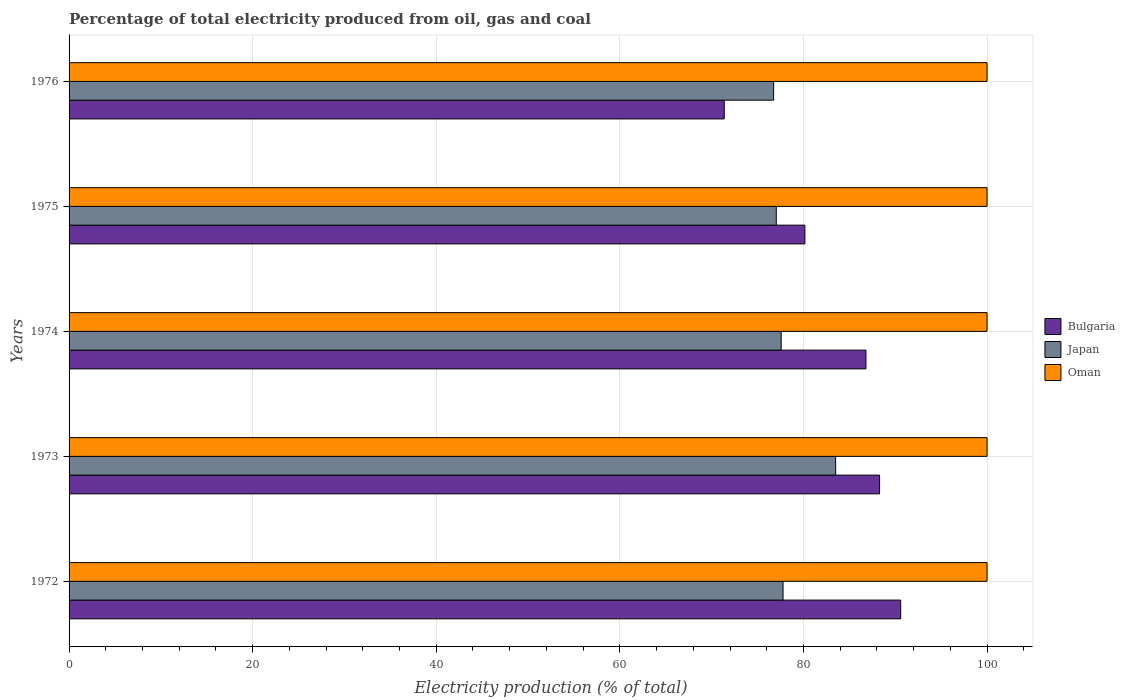How many groups of bars are there?
Provide a succinct answer. 5. Are the number of bars on each tick of the Y-axis equal?
Give a very brief answer. Yes. How many bars are there on the 2nd tick from the top?
Keep it short and to the point. 3. How many bars are there on the 3rd tick from the bottom?
Keep it short and to the point. 3. In how many cases, is the number of bars for a given year not equal to the number of legend labels?
Provide a short and direct response. 0. What is the electricity production in in Japan in 1975?
Ensure brevity in your answer.  77.04. Across all years, what is the maximum electricity production in in Bulgaria?
Make the answer very short. 90.59. Across all years, what is the minimum electricity production in in Bulgaria?
Your answer should be very brief. 71.37. In which year was the electricity production in in Japan minimum?
Give a very brief answer. 1976. What is the total electricity production in in Oman in the graph?
Your answer should be very brief. 500. What is the difference between the electricity production in in Japan in 1974 and that in 1975?
Make the answer very short. 0.53. What is the difference between the electricity production in in Japan in 1973 and the electricity production in in Oman in 1976?
Give a very brief answer. -16.49. What is the average electricity production in in Oman per year?
Your answer should be very brief. 100. In the year 1974, what is the difference between the electricity production in in Bulgaria and electricity production in in Oman?
Make the answer very short. -13.19. In how many years, is the electricity production in in Japan greater than 48 %?
Give a very brief answer. 5. Is the electricity production in in Oman in 1972 less than that in 1973?
Offer a very short reply. No. What is the difference between the highest and the second highest electricity production in in Japan?
Ensure brevity in your answer.  5.73. What does the 1st bar from the top in 1975 represents?
Provide a succinct answer. Oman. How many bars are there?
Make the answer very short. 15. Are all the bars in the graph horizontal?
Your response must be concise. Yes. What is the difference between two consecutive major ticks on the X-axis?
Give a very brief answer. 20. Does the graph contain any zero values?
Provide a succinct answer. No. Does the graph contain grids?
Your response must be concise. Yes. How many legend labels are there?
Your response must be concise. 3. How are the legend labels stacked?
Make the answer very short. Vertical. What is the title of the graph?
Offer a very short reply. Percentage of total electricity produced from oil, gas and coal. Does "Lebanon" appear as one of the legend labels in the graph?
Your answer should be compact. No. What is the label or title of the X-axis?
Ensure brevity in your answer.  Electricity production (% of total). What is the label or title of the Y-axis?
Offer a very short reply. Years. What is the Electricity production (% of total) in Bulgaria in 1972?
Your answer should be very brief. 90.59. What is the Electricity production (% of total) in Japan in 1972?
Provide a succinct answer. 77.78. What is the Electricity production (% of total) in Oman in 1972?
Keep it short and to the point. 100. What is the Electricity production (% of total) in Bulgaria in 1973?
Your answer should be very brief. 88.29. What is the Electricity production (% of total) of Japan in 1973?
Offer a very short reply. 83.51. What is the Electricity production (% of total) of Bulgaria in 1974?
Make the answer very short. 86.81. What is the Electricity production (% of total) in Japan in 1974?
Keep it short and to the point. 77.57. What is the Electricity production (% of total) in Oman in 1974?
Your answer should be compact. 100. What is the Electricity production (% of total) in Bulgaria in 1975?
Your answer should be compact. 80.16. What is the Electricity production (% of total) of Japan in 1975?
Your answer should be very brief. 77.04. What is the Electricity production (% of total) in Oman in 1975?
Offer a terse response. 100. What is the Electricity production (% of total) in Bulgaria in 1976?
Your answer should be compact. 71.37. What is the Electricity production (% of total) in Japan in 1976?
Keep it short and to the point. 76.75. Across all years, what is the maximum Electricity production (% of total) in Bulgaria?
Make the answer very short. 90.59. Across all years, what is the maximum Electricity production (% of total) in Japan?
Keep it short and to the point. 83.51. Across all years, what is the minimum Electricity production (% of total) of Bulgaria?
Your response must be concise. 71.37. Across all years, what is the minimum Electricity production (% of total) of Japan?
Make the answer very short. 76.75. Across all years, what is the minimum Electricity production (% of total) in Oman?
Your answer should be very brief. 100. What is the total Electricity production (% of total) of Bulgaria in the graph?
Offer a very short reply. 417.23. What is the total Electricity production (% of total) of Japan in the graph?
Keep it short and to the point. 392.65. What is the difference between the Electricity production (% of total) of Bulgaria in 1972 and that in 1973?
Offer a very short reply. 2.3. What is the difference between the Electricity production (% of total) in Japan in 1972 and that in 1973?
Keep it short and to the point. -5.73. What is the difference between the Electricity production (% of total) in Oman in 1972 and that in 1973?
Keep it short and to the point. 0. What is the difference between the Electricity production (% of total) in Bulgaria in 1972 and that in 1974?
Provide a succinct answer. 3.78. What is the difference between the Electricity production (% of total) of Japan in 1972 and that in 1974?
Ensure brevity in your answer.  0.2. What is the difference between the Electricity production (% of total) of Oman in 1972 and that in 1974?
Your answer should be very brief. 0. What is the difference between the Electricity production (% of total) of Bulgaria in 1972 and that in 1975?
Offer a very short reply. 10.43. What is the difference between the Electricity production (% of total) of Japan in 1972 and that in 1975?
Offer a terse response. 0.74. What is the difference between the Electricity production (% of total) of Oman in 1972 and that in 1975?
Ensure brevity in your answer.  0. What is the difference between the Electricity production (% of total) in Bulgaria in 1972 and that in 1976?
Provide a short and direct response. 19.22. What is the difference between the Electricity production (% of total) in Japan in 1972 and that in 1976?
Offer a very short reply. 1.03. What is the difference between the Electricity production (% of total) in Oman in 1972 and that in 1976?
Your answer should be very brief. 0. What is the difference between the Electricity production (% of total) in Bulgaria in 1973 and that in 1974?
Ensure brevity in your answer.  1.48. What is the difference between the Electricity production (% of total) of Japan in 1973 and that in 1974?
Keep it short and to the point. 5.93. What is the difference between the Electricity production (% of total) of Oman in 1973 and that in 1974?
Your answer should be compact. 0. What is the difference between the Electricity production (% of total) of Bulgaria in 1973 and that in 1975?
Offer a terse response. 8.13. What is the difference between the Electricity production (% of total) of Japan in 1973 and that in 1975?
Make the answer very short. 6.47. What is the difference between the Electricity production (% of total) of Bulgaria in 1973 and that in 1976?
Your answer should be compact. 16.92. What is the difference between the Electricity production (% of total) in Japan in 1973 and that in 1976?
Your answer should be compact. 6.76. What is the difference between the Electricity production (% of total) in Oman in 1973 and that in 1976?
Your response must be concise. 0. What is the difference between the Electricity production (% of total) in Bulgaria in 1974 and that in 1975?
Keep it short and to the point. 6.65. What is the difference between the Electricity production (% of total) in Japan in 1974 and that in 1975?
Offer a terse response. 0.53. What is the difference between the Electricity production (% of total) of Oman in 1974 and that in 1975?
Your response must be concise. 0. What is the difference between the Electricity production (% of total) of Bulgaria in 1974 and that in 1976?
Provide a succinct answer. 15.44. What is the difference between the Electricity production (% of total) in Japan in 1974 and that in 1976?
Provide a short and direct response. 0.82. What is the difference between the Electricity production (% of total) in Bulgaria in 1975 and that in 1976?
Make the answer very short. 8.79. What is the difference between the Electricity production (% of total) of Japan in 1975 and that in 1976?
Provide a succinct answer. 0.29. What is the difference between the Electricity production (% of total) in Oman in 1975 and that in 1976?
Provide a succinct answer. 0. What is the difference between the Electricity production (% of total) of Bulgaria in 1972 and the Electricity production (% of total) of Japan in 1973?
Your answer should be very brief. 7.09. What is the difference between the Electricity production (% of total) in Bulgaria in 1972 and the Electricity production (% of total) in Oman in 1973?
Your answer should be very brief. -9.41. What is the difference between the Electricity production (% of total) in Japan in 1972 and the Electricity production (% of total) in Oman in 1973?
Keep it short and to the point. -22.22. What is the difference between the Electricity production (% of total) of Bulgaria in 1972 and the Electricity production (% of total) of Japan in 1974?
Offer a terse response. 13.02. What is the difference between the Electricity production (% of total) of Bulgaria in 1972 and the Electricity production (% of total) of Oman in 1974?
Keep it short and to the point. -9.41. What is the difference between the Electricity production (% of total) of Japan in 1972 and the Electricity production (% of total) of Oman in 1974?
Your response must be concise. -22.22. What is the difference between the Electricity production (% of total) of Bulgaria in 1972 and the Electricity production (% of total) of Japan in 1975?
Ensure brevity in your answer.  13.55. What is the difference between the Electricity production (% of total) of Bulgaria in 1972 and the Electricity production (% of total) of Oman in 1975?
Make the answer very short. -9.41. What is the difference between the Electricity production (% of total) of Japan in 1972 and the Electricity production (% of total) of Oman in 1975?
Your response must be concise. -22.22. What is the difference between the Electricity production (% of total) in Bulgaria in 1972 and the Electricity production (% of total) in Japan in 1976?
Keep it short and to the point. 13.84. What is the difference between the Electricity production (% of total) in Bulgaria in 1972 and the Electricity production (% of total) in Oman in 1976?
Ensure brevity in your answer.  -9.41. What is the difference between the Electricity production (% of total) of Japan in 1972 and the Electricity production (% of total) of Oman in 1976?
Offer a very short reply. -22.22. What is the difference between the Electricity production (% of total) of Bulgaria in 1973 and the Electricity production (% of total) of Japan in 1974?
Your answer should be very brief. 10.72. What is the difference between the Electricity production (% of total) in Bulgaria in 1973 and the Electricity production (% of total) in Oman in 1974?
Provide a short and direct response. -11.71. What is the difference between the Electricity production (% of total) of Japan in 1973 and the Electricity production (% of total) of Oman in 1974?
Provide a succinct answer. -16.49. What is the difference between the Electricity production (% of total) of Bulgaria in 1973 and the Electricity production (% of total) of Japan in 1975?
Offer a very short reply. 11.25. What is the difference between the Electricity production (% of total) of Bulgaria in 1973 and the Electricity production (% of total) of Oman in 1975?
Provide a succinct answer. -11.71. What is the difference between the Electricity production (% of total) of Japan in 1973 and the Electricity production (% of total) of Oman in 1975?
Offer a terse response. -16.49. What is the difference between the Electricity production (% of total) of Bulgaria in 1973 and the Electricity production (% of total) of Japan in 1976?
Ensure brevity in your answer.  11.54. What is the difference between the Electricity production (% of total) of Bulgaria in 1973 and the Electricity production (% of total) of Oman in 1976?
Provide a short and direct response. -11.71. What is the difference between the Electricity production (% of total) in Japan in 1973 and the Electricity production (% of total) in Oman in 1976?
Your answer should be compact. -16.49. What is the difference between the Electricity production (% of total) of Bulgaria in 1974 and the Electricity production (% of total) of Japan in 1975?
Make the answer very short. 9.77. What is the difference between the Electricity production (% of total) of Bulgaria in 1974 and the Electricity production (% of total) of Oman in 1975?
Your answer should be compact. -13.19. What is the difference between the Electricity production (% of total) of Japan in 1974 and the Electricity production (% of total) of Oman in 1975?
Offer a very short reply. -22.43. What is the difference between the Electricity production (% of total) of Bulgaria in 1974 and the Electricity production (% of total) of Japan in 1976?
Provide a succinct answer. 10.06. What is the difference between the Electricity production (% of total) in Bulgaria in 1974 and the Electricity production (% of total) in Oman in 1976?
Provide a short and direct response. -13.19. What is the difference between the Electricity production (% of total) of Japan in 1974 and the Electricity production (% of total) of Oman in 1976?
Your answer should be compact. -22.43. What is the difference between the Electricity production (% of total) in Bulgaria in 1975 and the Electricity production (% of total) in Japan in 1976?
Keep it short and to the point. 3.41. What is the difference between the Electricity production (% of total) in Bulgaria in 1975 and the Electricity production (% of total) in Oman in 1976?
Provide a short and direct response. -19.84. What is the difference between the Electricity production (% of total) of Japan in 1975 and the Electricity production (% of total) of Oman in 1976?
Ensure brevity in your answer.  -22.96. What is the average Electricity production (% of total) of Bulgaria per year?
Provide a short and direct response. 83.45. What is the average Electricity production (% of total) in Japan per year?
Your response must be concise. 78.53. What is the average Electricity production (% of total) in Oman per year?
Offer a very short reply. 100. In the year 1972, what is the difference between the Electricity production (% of total) of Bulgaria and Electricity production (% of total) of Japan?
Keep it short and to the point. 12.82. In the year 1972, what is the difference between the Electricity production (% of total) of Bulgaria and Electricity production (% of total) of Oman?
Your answer should be very brief. -9.41. In the year 1972, what is the difference between the Electricity production (% of total) of Japan and Electricity production (% of total) of Oman?
Your answer should be compact. -22.22. In the year 1973, what is the difference between the Electricity production (% of total) of Bulgaria and Electricity production (% of total) of Japan?
Your answer should be very brief. 4.79. In the year 1973, what is the difference between the Electricity production (% of total) of Bulgaria and Electricity production (% of total) of Oman?
Provide a succinct answer. -11.71. In the year 1973, what is the difference between the Electricity production (% of total) in Japan and Electricity production (% of total) in Oman?
Give a very brief answer. -16.49. In the year 1974, what is the difference between the Electricity production (% of total) of Bulgaria and Electricity production (% of total) of Japan?
Your response must be concise. 9.24. In the year 1974, what is the difference between the Electricity production (% of total) in Bulgaria and Electricity production (% of total) in Oman?
Ensure brevity in your answer.  -13.19. In the year 1974, what is the difference between the Electricity production (% of total) in Japan and Electricity production (% of total) in Oman?
Ensure brevity in your answer.  -22.43. In the year 1975, what is the difference between the Electricity production (% of total) of Bulgaria and Electricity production (% of total) of Japan?
Your response must be concise. 3.12. In the year 1975, what is the difference between the Electricity production (% of total) in Bulgaria and Electricity production (% of total) in Oman?
Your response must be concise. -19.84. In the year 1975, what is the difference between the Electricity production (% of total) in Japan and Electricity production (% of total) in Oman?
Provide a succinct answer. -22.96. In the year 1976, what is the difference between the Electricity production (% of total) in Bulgaria and Electricity production (% of total) in Japan?
Your answer should be very brief. -5.38. In the year 1976, what is the difference between the Electricity production (% of total) in Bulgaria and Electricity production (% of total) in Oman?
Provide a succinct answer. -28.63. In the year 1976, what is the difference between the Electricity production (% of total) of Japan and Electricity production (% of total) of Oman?
Ensure brevity in your answer.  -23.25. What is the ratio of the Electricity production (% of total) in Bulgaria in 1972 to that in 1973?
Offer a very short reply. 1.03. What is the ratio of the Electricity production (% of total) of Japan in 1972 to that in 1973?
Offer a very short reply. 0.93. What is the ratio of the Electricity production (% of total) in Bulgaria in 1972 to that in 1974?
Provide a short and direct response. 1.04. What is the ratio of the Electricity production (% of total) in Bulgaria in 1972 to that in 1975?
Provide a succinct answer. 1.13. What is the ratio of the Electricity production (% of total) in Japan in 1972 to that in 1975?
Make the answer very short. 1.01. What is the ratio of the Electricity production (% of total) in Bulgaria in 1972 to that in 1976?
Offer a terse response. 1.27. What is the ratio of the Electricity production (% of total) in Japan in 1972 to that in 1976?
Make the answer very short. 1.01. What is the ratio of the Electricity production (% of total) in Bulgaria in 1973 to that in 1974?
Keep it short and to the point. 1.02. What is the ratio of the Electricity production (% of total) in Japan in 1973 to that in 1974?
Give a very brief answer. 1.08. What is the ratio of the Electricity production (% of total) of Bulgaria in 1973 to that in 1975?
Make the answer very short. 1.1. What is the ratio of the Electricity production (% of total) of Japan in 1973 to that in 1975?
Your response must be concise. 1.08. What is the ratio of the Electricity production (% of total) of Bulgaria in 1973 to that in 1976?
Offer a very short reply. 1.24. What is the ratio of the Electricity production (% of total) in Japan in 1973 to that in 1976?
Your answer should be very brief. 1.09. What is the ratio of the Electricity production (% of total) in Oman in 1973 to that in 1976?
Provide a short and direct response. 1. What is the ratio of the Electricity production (% of total) in Bulgaria in 1974 to that in 1975?
Your answer should be very brief. 1.08. What is the ratio of the Electricity production (% of total) of Bulgaria in 1974 to that in 1976?
Give a very brief answer. 1.22. What is the ratio of the Electricity production (% of total) of Japan in 1974 to that in 1976?
Your answer should be very brief. 1.01. What is the ratio of the Electricity production (% of total) of Oman in 1974 to that in 1976?
Offer a very short reply. 1. What is the ratio of the Electricity production (% of total) in Bulgaria in 1975 to that in 1976?
Your answer should be compact. 1.12. What is the ratio of the Electricity production (% of total) of Japan in 1975 to that in 1976?
Your answer should be very brief. 1. What is the difference between the highest and the second highest Electricity production (% of total) of Bulgaria?
Offer a very short reply. 2.3. What is the difference between the highest and the second highest Electricity production (% of total) in Japan?
Your response must be concise. 5.73. What is the difference between the highest and the second highest Electricity production (% of total) of Oman?
Ensure brevity in your answer.  0. What is the difference between the highest and the lowest Electricity production (% of total) of Bulgaria?
Make the answer very short. 19.22. What is the difference between the highest and the lowest Electricity production (% of total) of Japan?
Provide a short and direct response. 6.76. What is the difference between the highest and the lowest Electricity production (% of total) of Oman?
Ensure brevity in your answer.  0. 